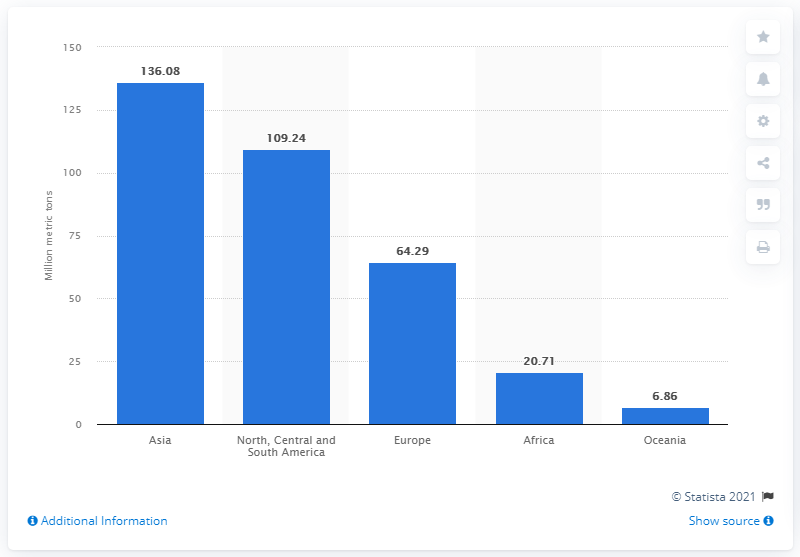Outline some significant characteristics in this image. In 2019, the net production of meat in Asia was 136.08 million metric tons. In 2019, the net production of meat in Europe was 64.29 million metric tons. 